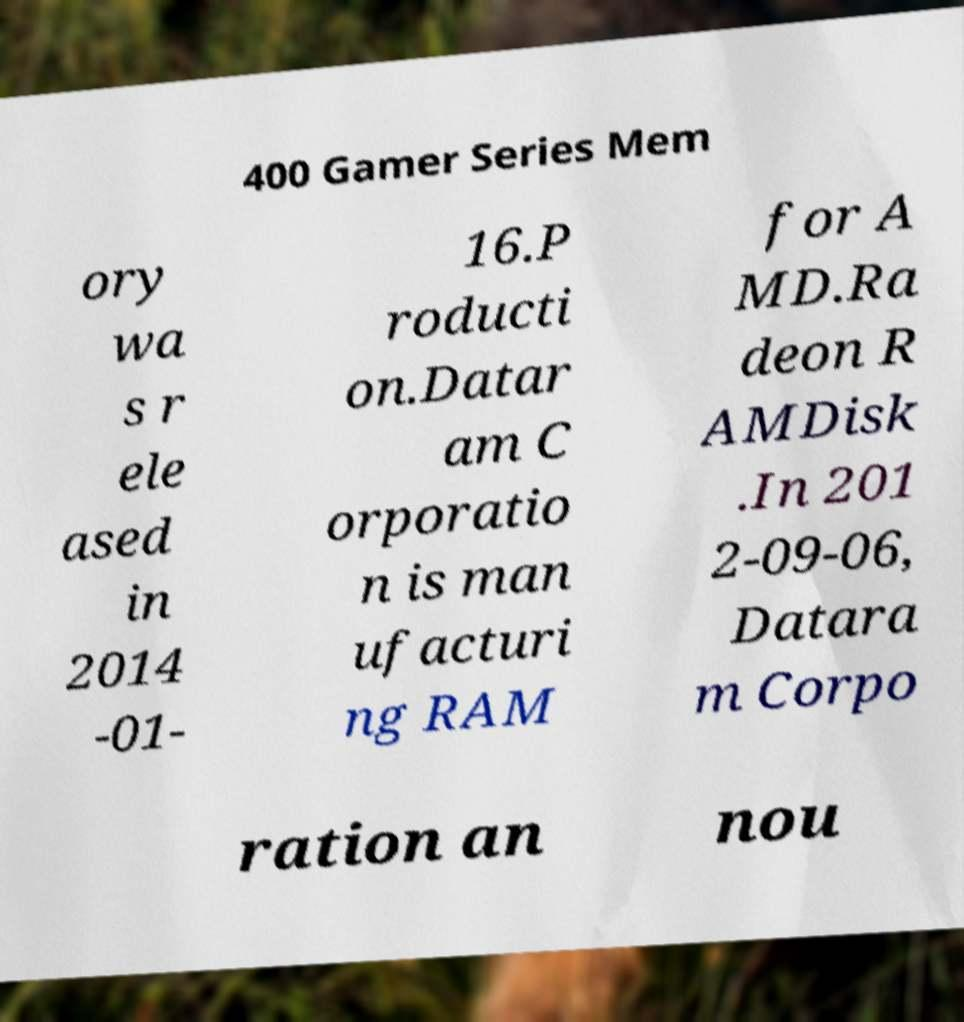Can you read and provide the text displayed in the image?This photo seems to have some interesting text. Can you extract and type it out for me? 400 Gamer Series Mem ory wa s r ele ased in 2014 -01- 16.P roducti on.Datar am C orporatio n is man ufacturi ng RAM for A MD.Ra deon R AMDisk .In 201 2-09-06, Datara m Corpo ration an nou 